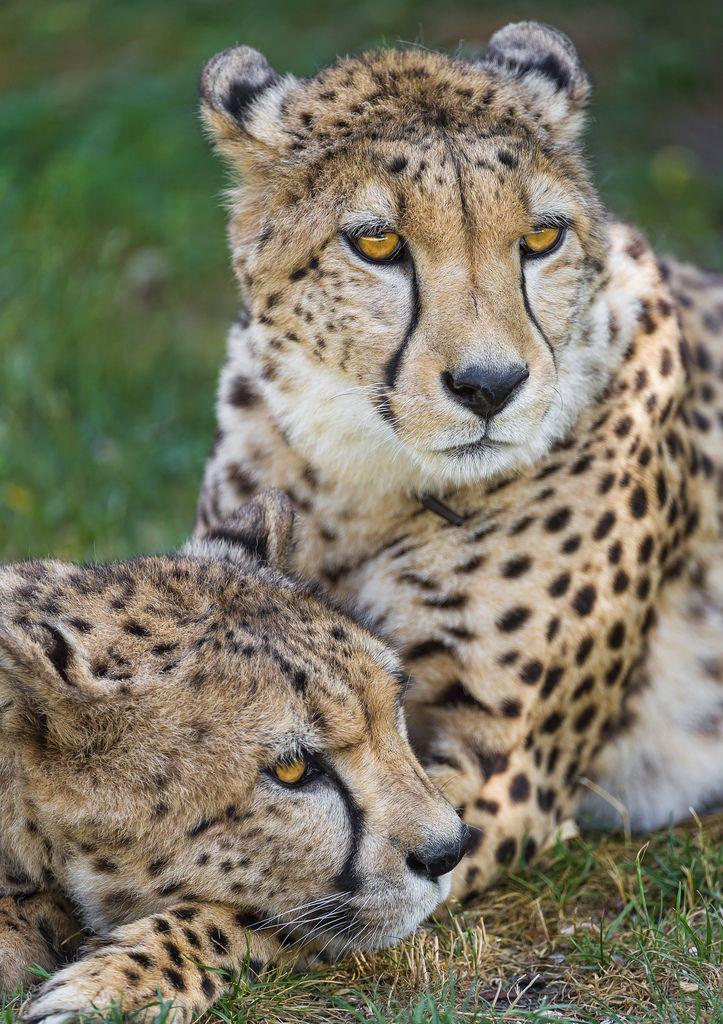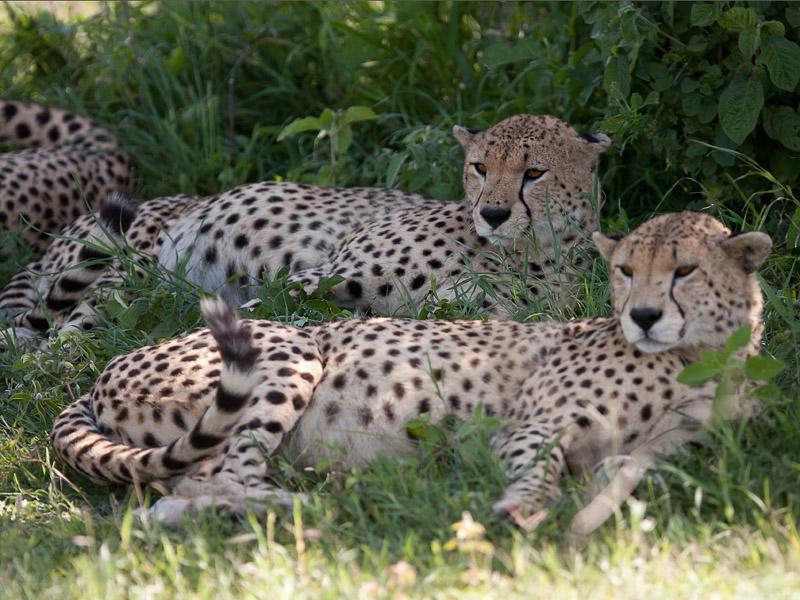The first image is the image on the left, the second image is the image on the right. Examine the images to the left and right. Is the description "There are at least two leopards laying down on their sides together in one of the images." accurate? Answer yes or no. Yes. The first image is the image on the left, the second image is the image on the right. Given the left and right images, does the statement "There are 5 or more cheetahs." hold true? Answer yes or no. Yes. 